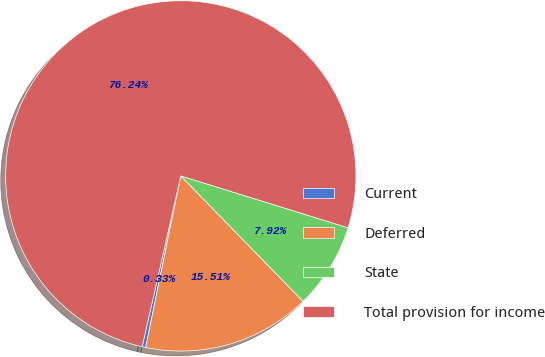Convert chart to OTSL. <chart><loc_0><loc_0><loc_500><loc_500><pie_chart><fcel>Current<fcel>Deferred<fcel>State<fcel>Total provision for income<nl><fcel>0.33%<fcel>15.51%<fcel>7.92%<fcel>76.25%<nl></chart> 